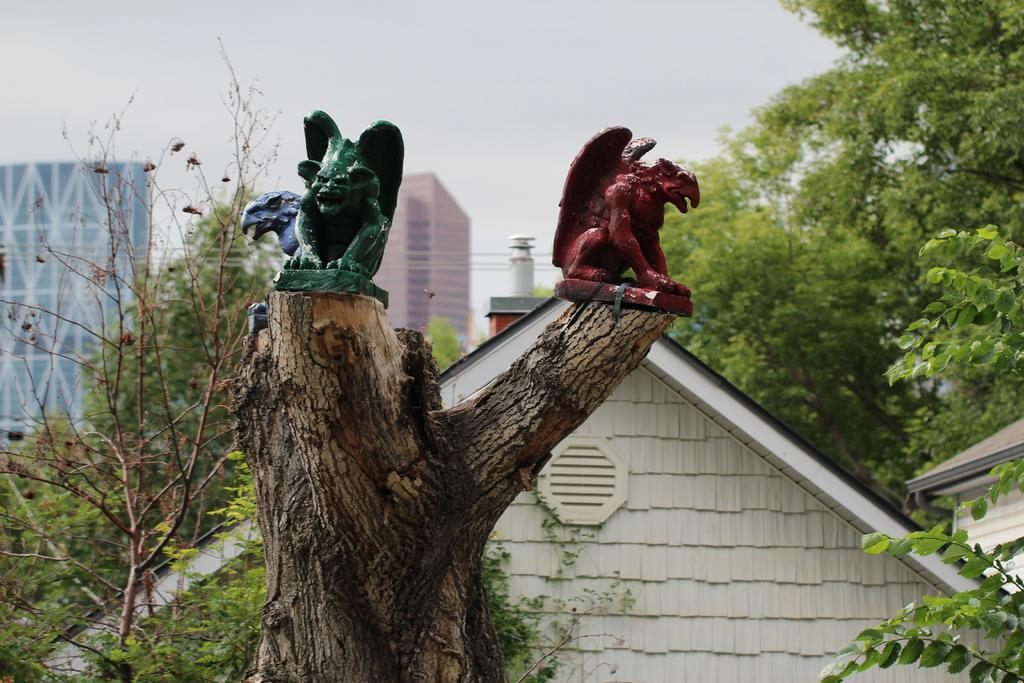What is the main subject of the image? The main subject of the image is a tree trunk. What is unique about the tree trunk? The tree trunk has sculptures of different colors on it. What else can be seen in the image besides the tree trunk? There are buildings and trees visible in the image. What is visible in the background of the image? The sky is visible in the image. What type of thread is used to create the sculptures on the tree trunk? There is no mention of thread being used to create the sculptures on the tree trunk; they are made of a different material. What kind of test is being conducted in the image? There is no indication of a test being conducted in the image. 